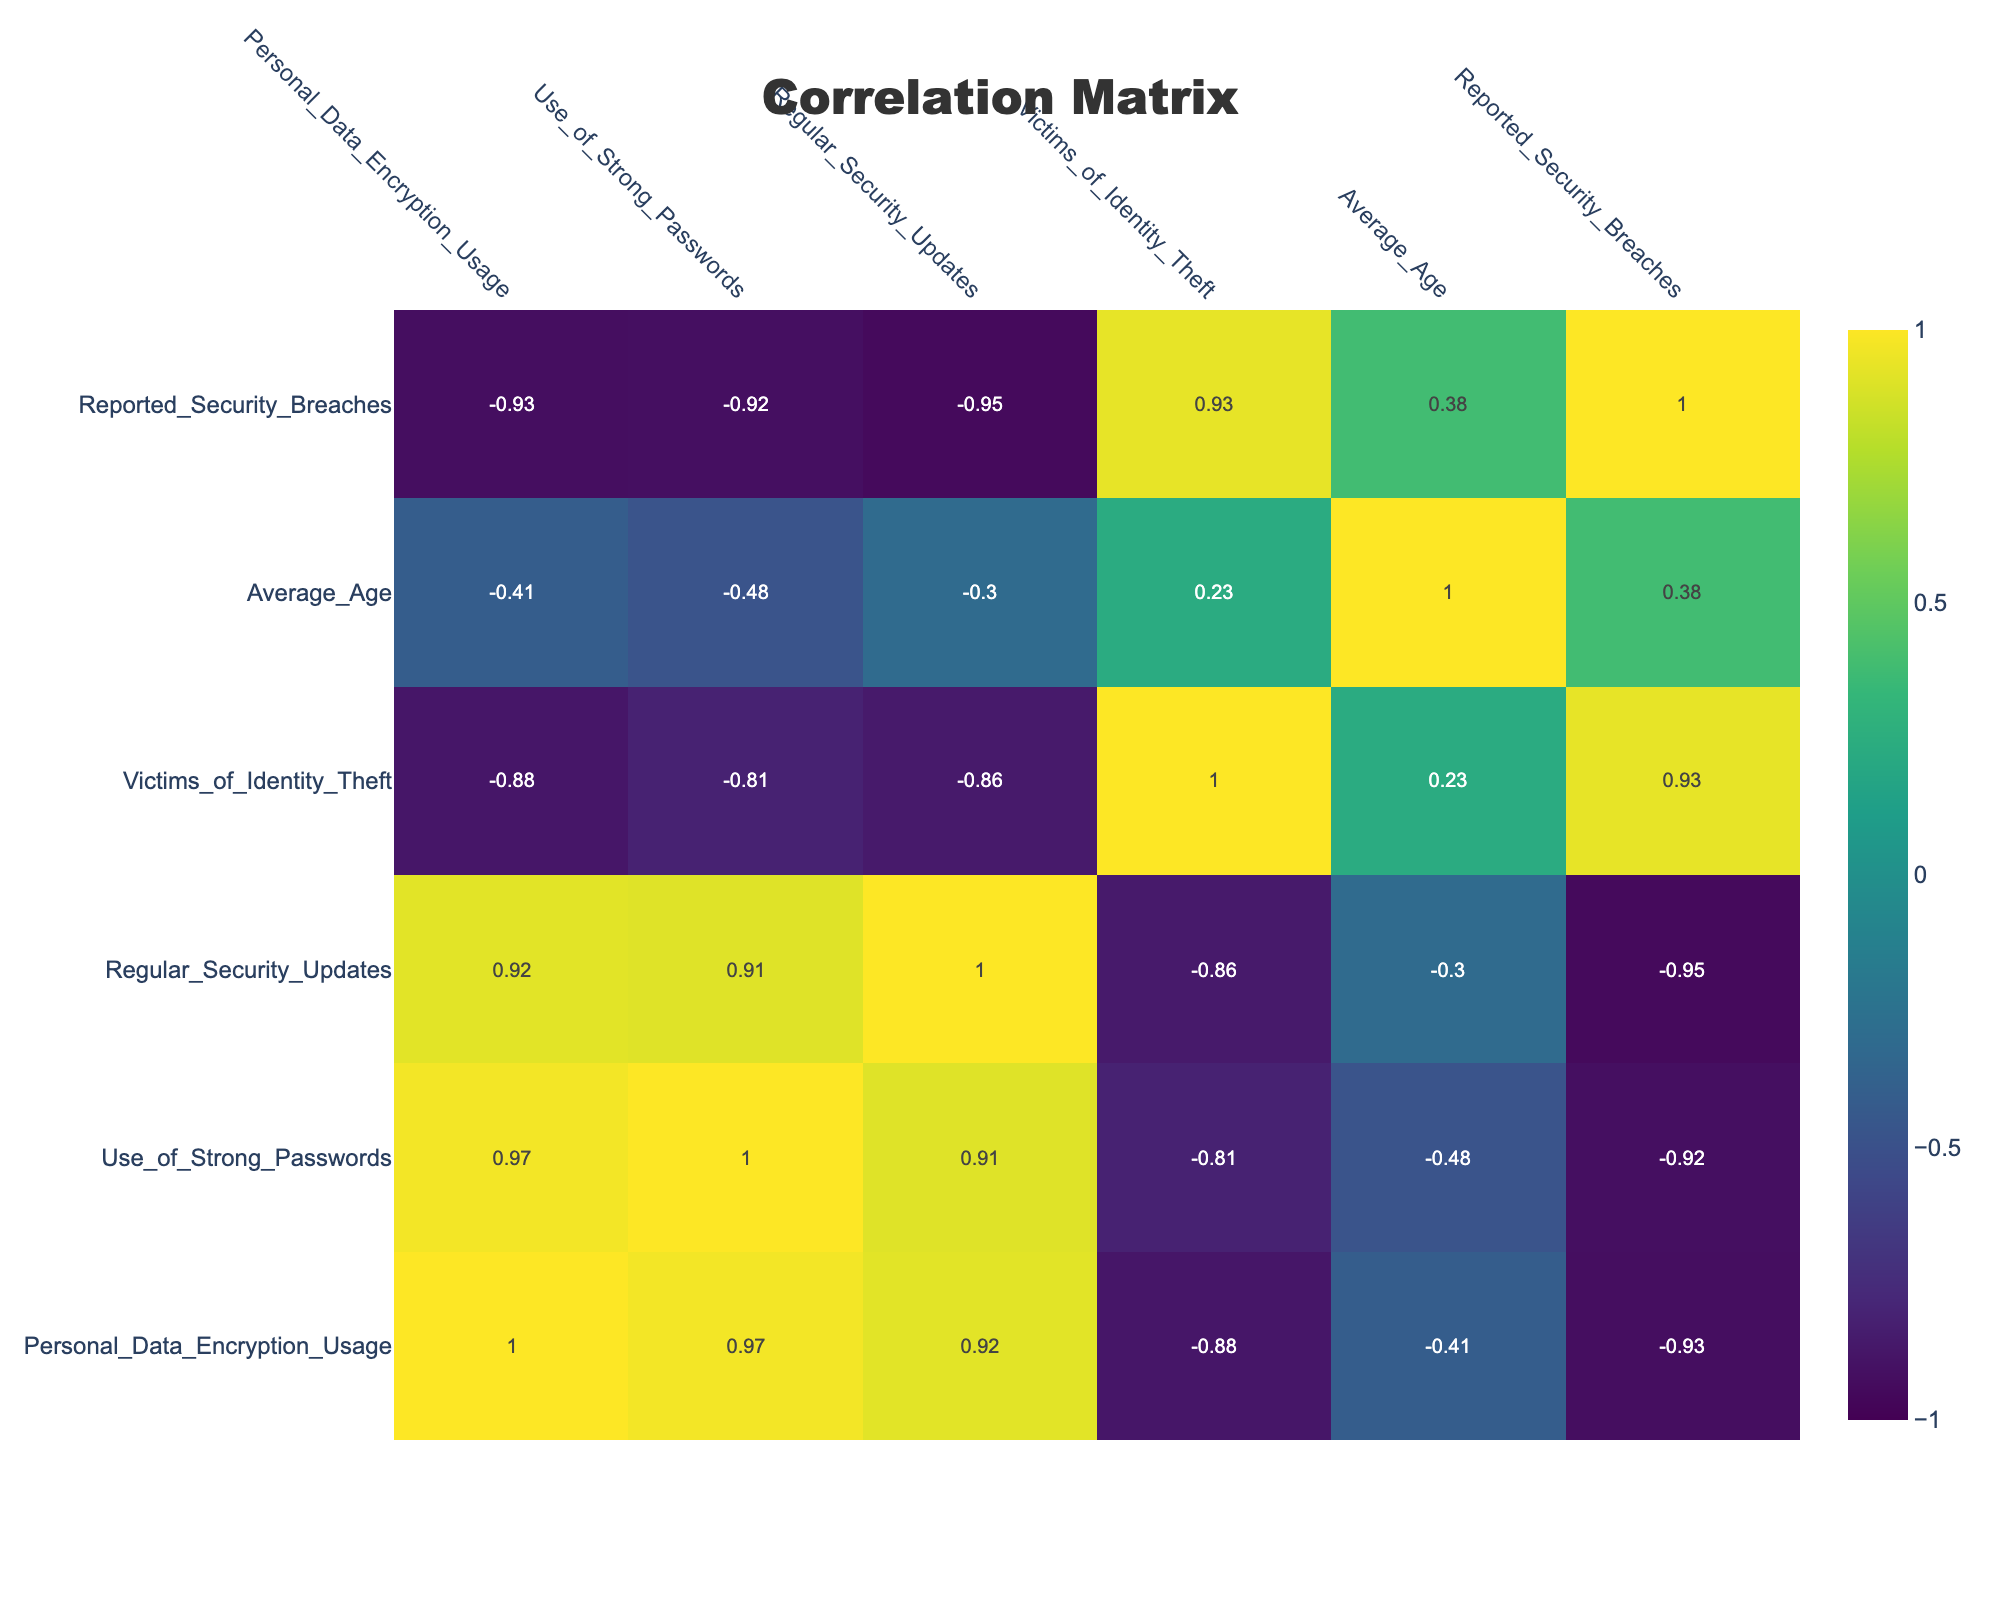What is the average usage of strong passwords among all demographic groups? To find the average usage of strong passwords, I will sum the values for strong password usage (0.85 + 0.80 + 0.60 + 0.90 + 0.50 + 0.75 + 0.90 + 0.70 + 0.55) which equals 6.55. There are 9 demographic groups, so the average is 6.55 / 9 = approximately 0.728.
Answer: 0.728 Is there a correlation between personal data encryption usage and the number of victims of identity theft? I will check the correlation value from the table for personal data encryption usage and victims of identity theft. The correlation is a positive number, indicating that as encryption usage increases, the number of identity theft victims tends to decrease.
Answer: Yes Which demographic group has the highest reported security breaches? I will look through the reported security breaches and identify the maximum value. The Low-Income group has 25 reported security breaches, which is the highest.
Answer: Low-Income What is the difference in average age between the Baby Boomers and Generation Z? The average age of Baby Boomers is 65 and for Generation Z is 23. The difference is calculated as 65 - 23 = 42.
Answer: 42 Are there more victims of identity theft among the Low-Income group compared to the High-Income group? The Low-Income group has 30 victims of identity theft while the High-Income group has only 5. Thus, the Low-Income group experiences more victimization.
Answer: Yes What is the median reported security breaches among different demographic groups? The reported security breaches are: 15, 10, 20, 5, 25, 10, 5, 15, 20. When sorted, these values become: 5, 5, 10, 10, 15, 15, 20, 20, 25. The median is the middle value which, in this case, is 15.
Answer: 15 Do younger demographic groups generally have higher personal data encryption usage? A comparison shows that younger groups (Generation Z and Millennials) have higher encryption usage (0.78, 0.72) compared to older groups (Baby Boomers have 0.50), indicating a trend of higher usage in younger demographics.
Answer: Yes What percentage of the Millennials are victims of identity theft compared to the average across all demographic groups? Millennials have 20 victims out of a total of 105 (20 + 15 + 25 + 10 + 30 + 15 + 5 + 20), which equals approximately 19%. The average victim count across all groups is 105 / 9 = 11.67, so the percentage for Millennials is higher comparatively.
Answer: Millennials have a higher percentage 